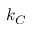<formula> <loc_0><loc_0><loc_500><loc_500>k _ { C }</formula> 